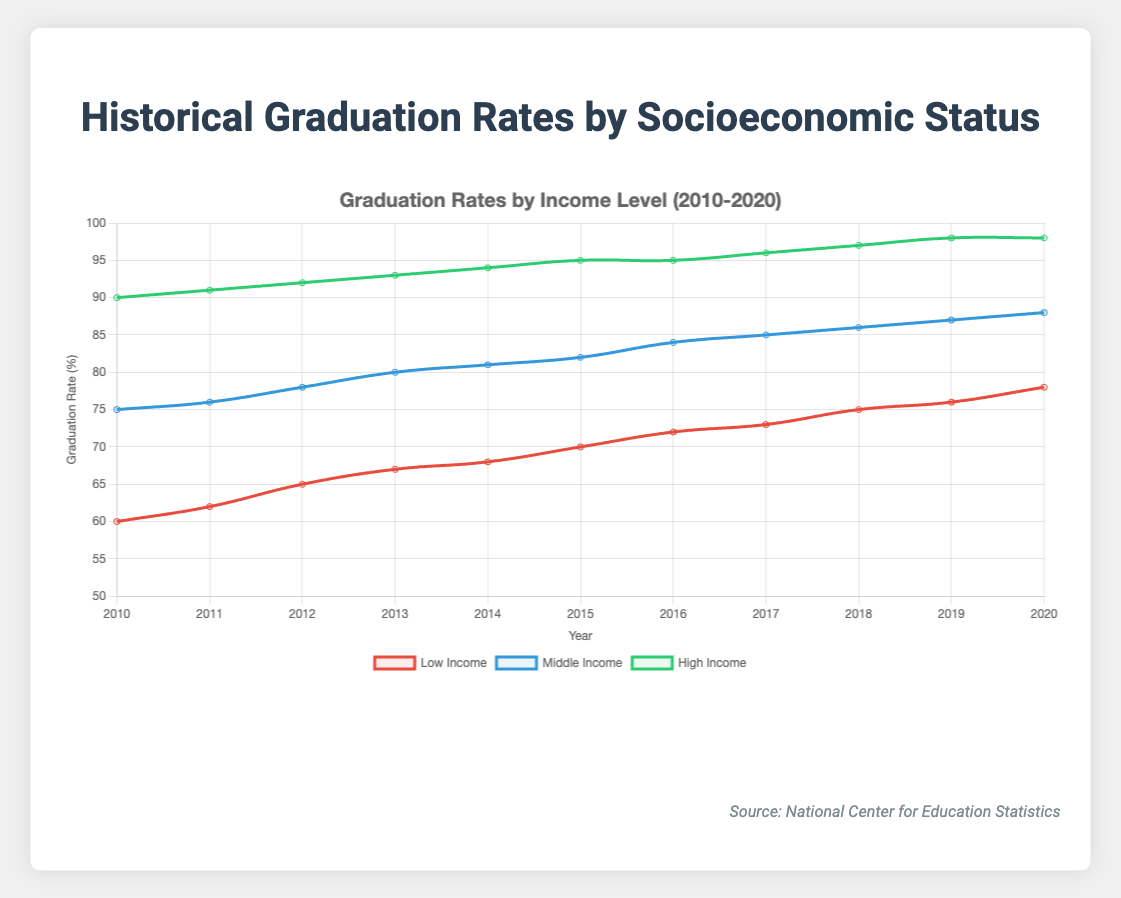What is the graduation rate for middle-income students in 2014? To find the graduation rate for middle-income students in 2014, locate the year 2014 on the x-axis and check the corresponding value for the middle-income group, represented by the blue line.
Answer: 81% Which income group had the highest graduation rate in 2012? To determine which income group had the highest graduation rate, look at the data points for 2012. The high-income group (green line) has the highest value.
Answer: High-income By how many percentage points did the low-income graduation rate increase from 2010 to 2020? Locate the years 2010 and 2020 on the x-axis for the low-income group (red line). The values are 60 for 2010 and 78 for 2020. Subtract the 2010 value from the 2020 value: 78 - 60.
Answer: 18 percentage points Which year did the middle-income and high-income graduation rates have the smallest gap? Calculate the difference between the middle-income and high-income graduation rates for each year. The smallest gap is in 2010, with values 75 (middle-income) and 90 (high-income), resulting in a difference of 15.
Answer: 2010 What is the average graduation rate for high-income students between 2010 and 2020? Sum the graduation rates for high-income students from all years and divide by the number of years: (90 + 91 + 92 + 93 + 94 + 95 + 95 + 96 + 97 + 98 + 98) / 11.
Answer: 94.18% How does the graduation rate trend for low-income students compare to middle-income students from 2010 to 2020? Both groups show an increasing trend, but the rate of increase is different. The low-income rates increased from 60 to 78, while middle-income rates increased from 75 to 88. The low-income group shows a steady rise with occasional accelerations, while the middle-income group shows a more gradual and consistent increase.
Answer: Both trends are increasing, low-income increases faster proportionally In which year did high-income students reach a graduation rate of at least 95%? Check the high-income group (green line) values to see when they first hit or exceed 95%. This occurs in 2015.
Answer: 2015 How much higher was the graduation rate for high-income students compared to low-income students in 2020? Locate the 2020 values for both high-income (98) and low-income (78) groups. Subtract the low-income rate from the high-income rate: 98 - 78.
Answer: 20 percentage points Which income group had the lowest graduation rate in 2019, and what was the rate? Look at the values for all three income groups in 2019. The low-income group has the lowest rate, which was 76%.
Answer: Low-income, 76% What is the overall trend observed in graduation rates for all income groups from 2010 to 2020? Analyze the lines representing each income group over the years. All three groups (low, middle, and high income) show a clear upward trend from 2010 to 2020, indicating an overall improvement in graduation rates.
Answer: Increasing for all groups 